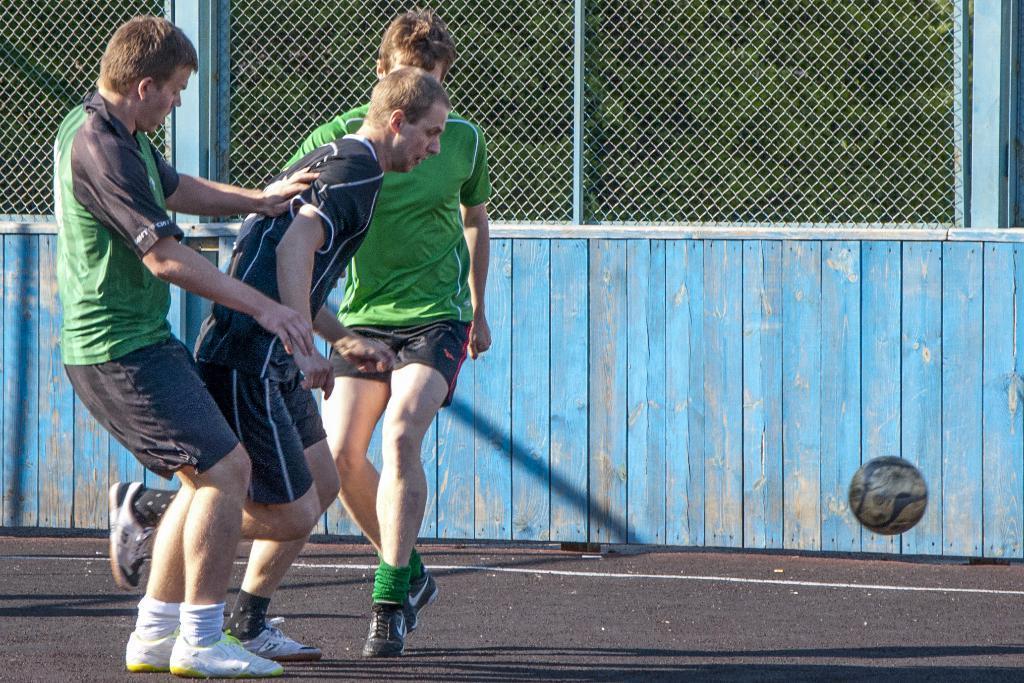Describe this image in one or two sentences. On the left side of the image three mans are standing. On the right side of the image a ball is there. In the background of the image we can see wall, mesh. At the bottom of the image there is a road. 